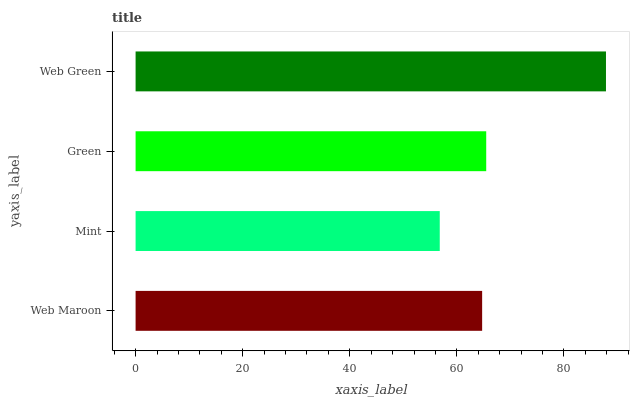Is Mint the minimum?
Answer yes or no. Yes. Is Web Green the maximum?
Answer yes or no. Yes. Is Green the minimum?
Answer yes or no. No. Is Green the maximum?
Answer yes or no. No. Is Green greater than Mint?
Answer yes or no. Yes. Is Mint less than Green?
Answer yes or no. Yes. Is Mint greater than Green?
Answer yes or no. No. Is Green less than Mint?
Answer yes or no. No. Is Green the high median?
Answer yes or no. Yes. Is Web Maroon the low median?
Answer yes or no. Yes. Is Mint the high median?
Answer yes or no. No. Is Green the low median?
Answer yes or no. No. 